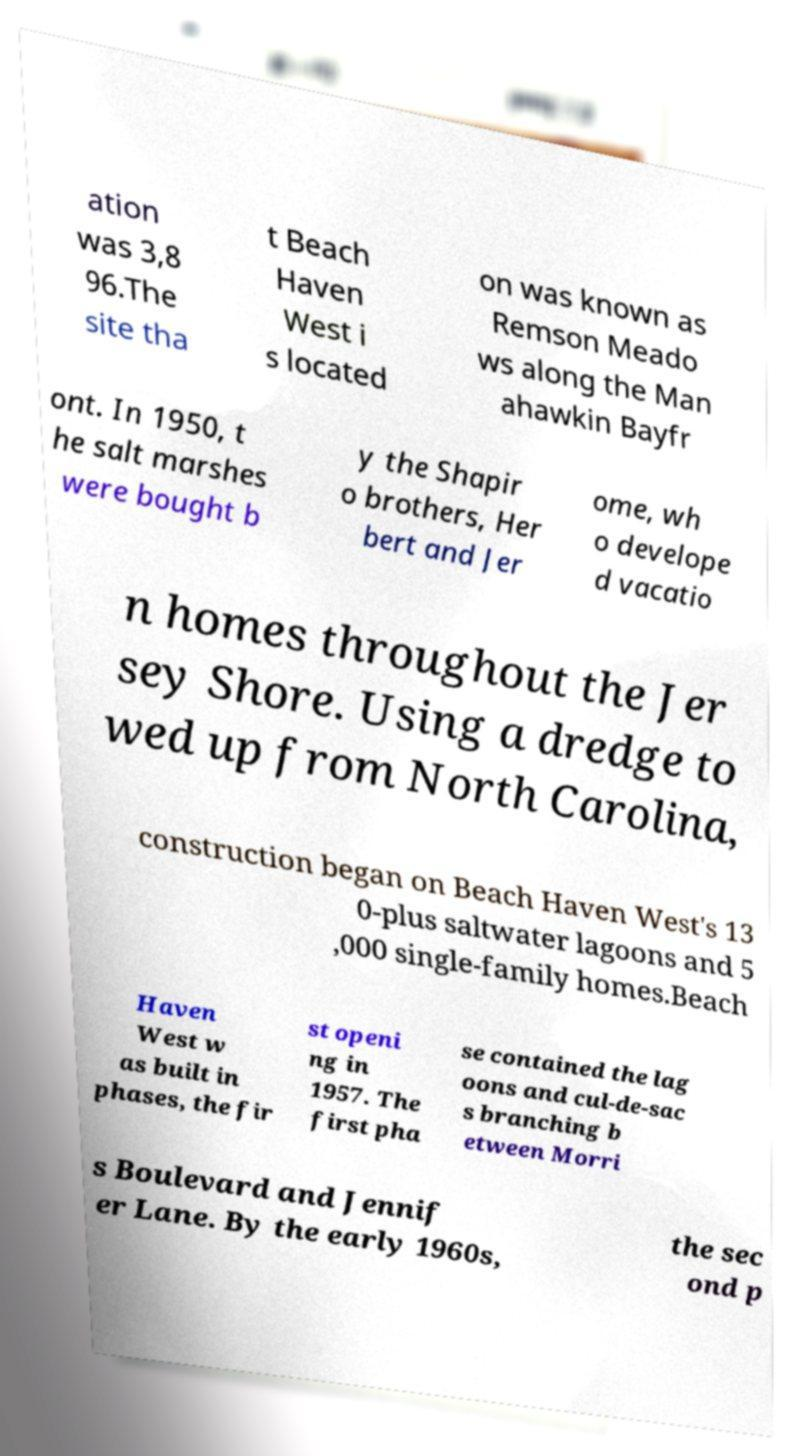What messages or text are displayed in this image? I need them in a readable, typed format. ation was 3,8 96.The site tha t Beach Haven West i s located on was known as Remson Meado ws along the Man ahawkin Bayfr ont. In 1950, t he salt marshes were bought b y the Shapir o brothers, Her bert and Jer ome, wh o develope d vacatio n homes throughout the Jer sey Shore. Using a dredge to wed up from North Carolina, construction began on Beach Haven West's 13 0-plus saltwater lagoons and 5 ,000 single-family homes.Beach Haven West w as built in phases, the fir st openi ng in 1957. The first pha se contained the lag oons and cul-de-sac s branching b etween Morri s Boulevard and Jennif er Lane. By the early 1960s, the sec ond p 